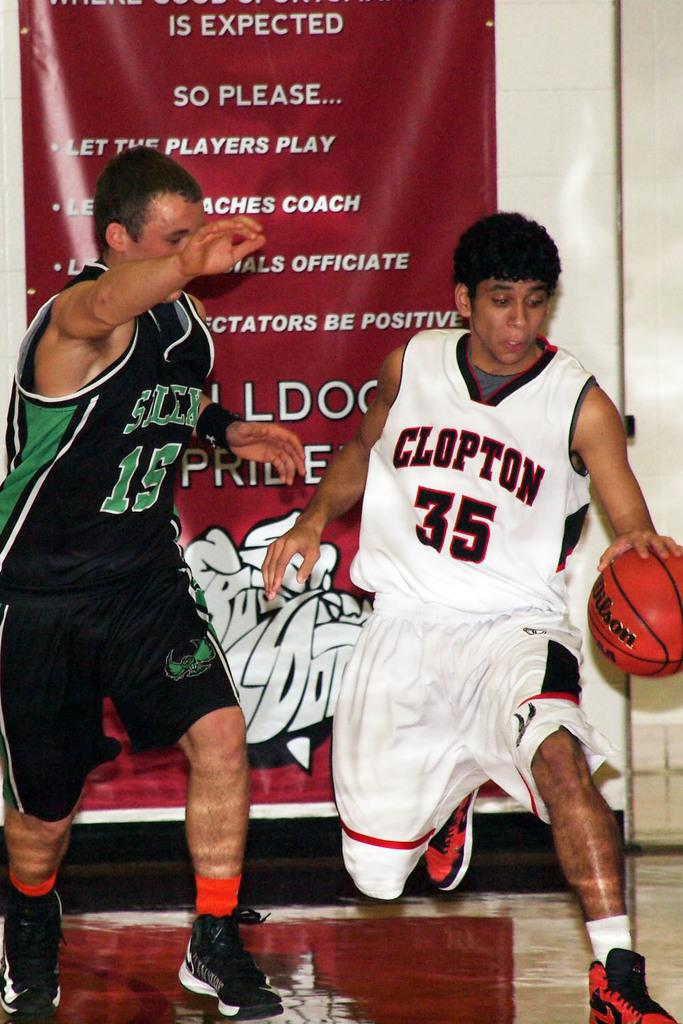<image>
Offer a succinct explanation of the picture presented. basketball players #35 for clopton in white going against #15 for silex in black 